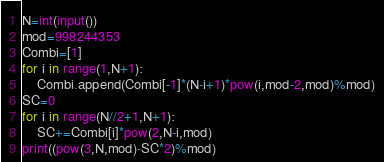Convert code to text. <code><loc_0><loc_0><loc_500><loc_500><_Python_>N=int(input())
mod=998244353
Combi=[1]
for i in range(1,N+1):
    Combi.append(Combi[-1]*(N-i+1)*pow(i,mod-2,mod)%mod)
SC=0
for i in range(N//2+1,N+1):
    SC+=Combi[i]*pow(2,N-i,mod)
print((pow(3,N,mod)-SC*2)%mod)</code> 